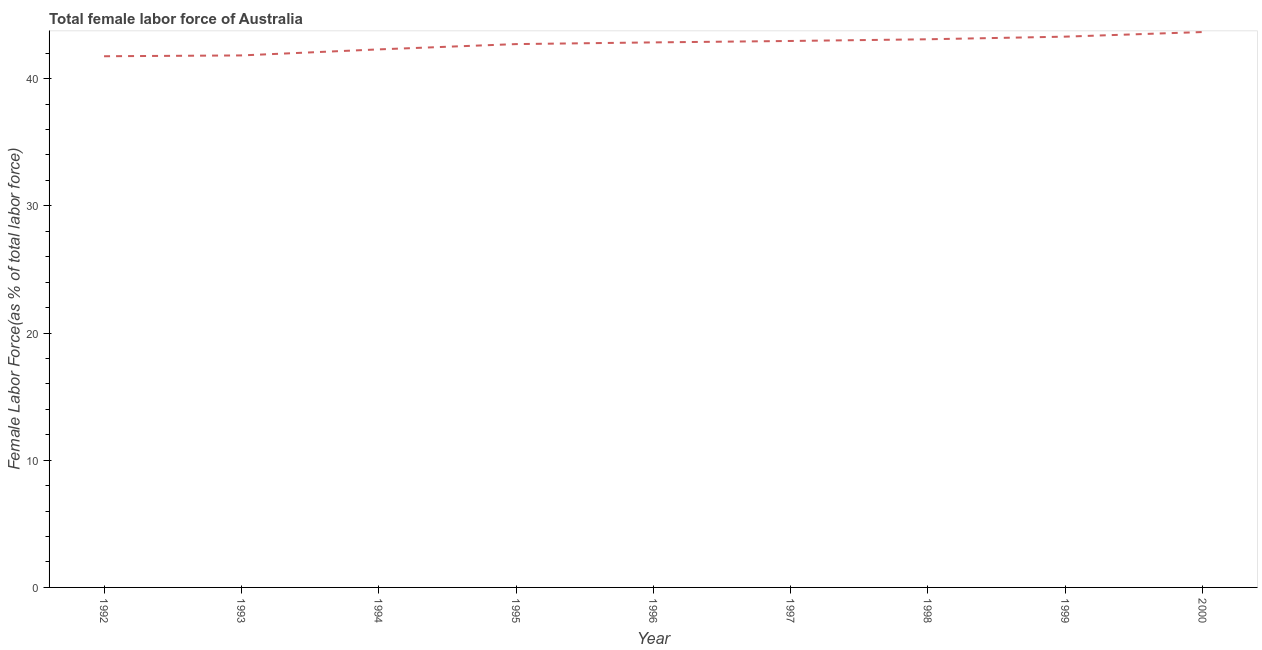What is the total female labor force in 1992?
Provide a short and direct response. 41.76. Across all years, what is the maximum total female labor force?
Offer a very short reply. 43.67. Across all years, what is the minimum total female labor force?
Make the answer very short. 41.76. In which year was the total female labor force minimum?
Your answer should be compact. 1992. What is the sum of the total female labor force?
Make the answer very short. 384.5. What is the difference between the total female labor force in 1993 and 1996?
Your answer should be very brief. -1.02. What is the average total female labor force per year?
Give a very brief answer. 42.72. What is the median total female labor force?
Give a very brief answer. 42.85. In how many years, is the total female labor force greater than 36 %?
Provide a succinct answer. 9. What is the ratio of the total female labor force in 1993 to that in 1998?
Keep it short and to the point. 0.97. Is the total female labor force in 1994 less than that in 1996?
Keep it short and to the point. Yes. Is the difference between the total female labor force in 1998 and 2000 greater than the difference between any two years?
Give a very brief answer. No. What is the difference between the highest and the second highest total female labor force?
Your response must be concise. 0.36. Is the sum of the total female labor force in 1995 and 1996 greater than the maximum total female labor force across all years?
Your answer should be very brief. Yes. What is the difference between the highest and the lowest total female labor force?
Provide a succinct answer. 1.9. Does the total female labor force monotonically increase over the years?
Give a very brief answer. Yes. How many years are there in the graph?
Provide a short and direct response. 9. Are the values on the major ticks of Y-axis written in scientific E-notation?
Provide a short and direct response. No. Does the graph contain any zero values?
Provide a succinct answer. No. Does the graph contain grids?
Make the answer very short. No. What is the title of the graph?
Your answer should be compact. Total female labor force of Australia. What is the label or title of the X-axis?
Your response must be concise. Year. What is the label or title of the Y-axis?
Keep it short and to the point. Female Labor Force(as % of total labor force). What is the Female Labor Force(as % of total labor force) of 1992?
Keep it short and to the point. 41.76. What is the Female Labor Force(as % of total labor force) in 1993?
Offer a terse response. 41.83. What is the Female Labor Force(as % of total labor force) in 1994?
Offer a terse response. 42.3. What is the Female Labor Force(as % of total labor force) of 1995?
Offer a very short reply. 42.72. What is the Female Labor Force(as % of total labor force) of 1996?
Your answer should be very brief. 42.85. What is the Female Labor Force(as % of total labor force) in 1997?
Keep it short and to the point. 42.97. What is the Female Labor Force(as % of total labor force) of 1998?
Make the answer very short. 43.1. What is the Female Labor Force(as % of total labor force) of 1999?
Offer a terse response. 43.31. What is the Female Labor Force(as % of total labor force) in 2000?
Provide a succinct answer. 43.67. What is the difference between the Female Labor Force(as % of total labor force) in 1992 and 1993?
Provide a succinct answer. -0.06. What is the difference between the Female Labor Force(as % of total labor force) in 1992 and 1994?
Provide a short and direct response. -0.54. What is the difference between the Female Labor Force(as % of total labor force) in 1992 and 1995?
Offer a terse response. -0.95. What is the difference between the Female Labor Force(as % of total labor force) in 1992 and 1996?
Provide a succinct answer. -1.09. What is the difference between the Female Labor Force(as % of total labor force) in 1992 and 1997?
Make the answer very short. -1.2. What is the difference between the Female Labor Force(as % of total labor force) in 1992 and 1998?
Offer a very short reply. -1.33. What is the difference between the Female Labor Force(as % of total labor force) in 1992 and 1999?
Your response must be concise. -1.54. What is the difference between the Female Labor Force(as % of total labor force) in 1992 and 2000?
Offer a very short reply. -1.9. What is the difference between the Female Labor Force(as % of total labor force) in 1993 and 1994?
Provide a short and direct response. -0.47. What is the difference between the Female Labor Force(as % of total labor force) in 1993 and 1995?
Provide a succinct answer. -0.89. What is the difference between the Female Labor Force(as % of total labor force) in 1993 and 1996?
Ensure brevity in your answer.  -1.02. What is the difference between the Female Labor Force(as % of total labor force) in 1993 and 1997?
Make the answer very short. -1.14. What is the difference between the Female Labor Force(as % of total labor force) in 1993 and 1998?
Keep it short and to the point. -1.27. What is the difference between the Female Labor Force(as % of total labor force) in 1993 and 1999?
Give a very brief answer. -1.48. What is the difference between the Female Labor Force(as % of total labor force) in 1993 and 2000?
Give a very brief answer. -1.84. What is the difference between the Female Labor Force(as % of total labor force) in 1994 and 1995?
Make the answer very short. -0.42. What is the difference between the Female Labor Force(as % of total labor force) in 1994 and 1996?
Provide a short and direct response. -0.55. What is the difference between the Female Labor Force(as % of total labor force) in 1994 and 1997?
Offer a very short reply. -0.66. What is the difference between the Female Labor Force(as % of total labor force) in 1994 and 1998?
Your answer should be compact. -0.8. What is the difference between the Female Labor Force(as % of total labor force) in 1994 and 1999?
Make the answer very short. -1. What is the difference between the Female Labor Force(as % of total labor force) in 1994 and 2000?
Provide a succinct answer. -1.36. What is the difference between the Female Labor Force(as % of total labor force) in 1995 and 1996?
Offer a very short reply. -0.13. What is the difference between the Female Labor Force(as % of total labor force) in 1995 and 1997?
Give a very brief answer. -0.25. What is the difference between the Female Labor Force(as % of total labor force) in 1995 and 1998?
Offer a very short reply. -0.38. What is the difference between the Female Labor Force(as % of total labor force) in 1995 and 1999?
Make the answer very short. -0.59. What is the difference between the Female Labor Force(as % of total labor force) in 1995 and 2000?
Offer a terse response. -0.95. What is the difference between the Female Labor Force(as % of total labor force) in 1996 and 1997?
Keep it short and to the point. -0.11. What is the difference between the Female Labor Force(as % of total labor force) in 1996 and 1998?
Ensure brevity in your answer.  -0.25. What is the difference between the Female Labor Force(as % of total labor force) in 1996 and 1999?
Offer a very short reply. -0.45. What is the difference between the Female Labor Force(as % of total labor force) in 1996 and 2000?
Ensure brevity in your answer.  -0.81. What is the difference between the Female Labor Force(as % of total labor force) in 1997 and 1998?
Keep it short and to the point. -0.13. What is the difference between the Female Labor Force(as % of total labor force) in 1997 and 1999?
Your answer should be very brief. -0.34. What is the difference between the Female Labor Force(as % of total labor force) in 1997 and 2000?
Your answer should be compact. -0.7. What is the difference between the Female Labor Force(as % of total labor force) in 1998 and 1999?
Offer a very short reply. -0.21. What is the difference between the Female Labor Force(as % of total labor force) in 1998 and 2000?
Give a very brief answer. -0.57. What is the difference between the Female Labor Force(as % of total labor force) in 1999 and 2000?
Your answer should be very brief. -0.36. What is the ratio of the Female Labor Force(as % of total labor force) in 1992 to that in 1995?
Provide a succinct answer. 0.98. What is the ratio of the Female Labor Force(as % of total labor force) in 1992 to that in 1996?
Provide a short and direct response. 0.97. What is the ratio of the Female Labor Force(as % of total labor force) in 1992 to that in 1999?
Offer a very short reply. 0.96. What is the ratio of the Female Labor Force(as % of total labor force) in 1992 to that in 2000?
Offer a very short reply. 0.96. What is the ratio of the Female Labor Force(as % of total labor force) in 1993 to that in 1994?
Make the answer very short. 0.99. What is the ratio of the Female Labor Force(as % of total labor force) in 1993 to that in 1996?
Offer a terse response. 0.98. What is the ratio of the Female Labor Force(as % of total labor force) in 1993 to that in 1999?
Keep it short and to the point. 0.97. What is the ratio of the Female Labor Force(as % of total labor force) in 1993 to that in 2000?
Give a very brief answer. 0.96. What is the ratio of the Female Labor Force(as % of total labor force) in 1994 to that in 1997?
Your response must be concise. 0.98. What is the ratio of the Female Labor Force(as % of total labor force) in 1994 to that in 1999?
Provide a short and direct response. 0.98. What is the ratio of the Female Labor Force(as % of total labor force) in 1994 to that in 2000?
Provide a short and direct response. 0.97. What is the ratio of the Female Labor Force(as % of total labor force) in 1995 to that in 1996?
Offer a terse response. 1. What is the ratio of the Female Labor Force(as % of total labor force) in 1995 to that in 1997?
Keep it short and to the point. 0.99. What is the ratio of the Female Labor Force(as % of total labor force) in 1995 to that in 1999?
Make the answer very short. 0.99. What is the ratio of the Female Labor Force(as % of total labor force) in 1995 to that in 2000?
Offer a very short reply. 0.98. What is the ratio of the Female Labor Force(as % of total labor force) in 1996 to that in 1997?
Give a very brief answer. 1. What is the ratio of the Female Labor Force(as % of total labor force) in 1996 to that in 1998?
Provide a short and direct response. 0.99. What is the ratio of the Female Labor Force(as % of total labor force) in 1997 to that in 1999?
Ensure brevity in your answer.  0.99. What is the ratio of the Female Labor Force(as % of total labor force) in 1997 to that in 2000?
Offer a terse response. 0.98. 